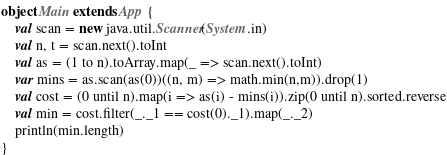<code> <loc_0><loc_0><loc_500><loc_500><_Scala_>object Main extends App {
    val scan = new java.util.Scanner(System.in)
    val n, t = scan.next().toInt
    val as = (1 to n).toArray.map(_ => scan.next().toInt)
    var mins = as.scan(as(0))((n, m) => math.min(n,m)).drop(1)
    val cost = (0 until n).map(i => as(i) - mins(i)).zip(0 until n).sorted.reverse
    val min = cost.filter(_._1 == cost(0)._1).map(_._2)
    println(min.length)
}</code> 